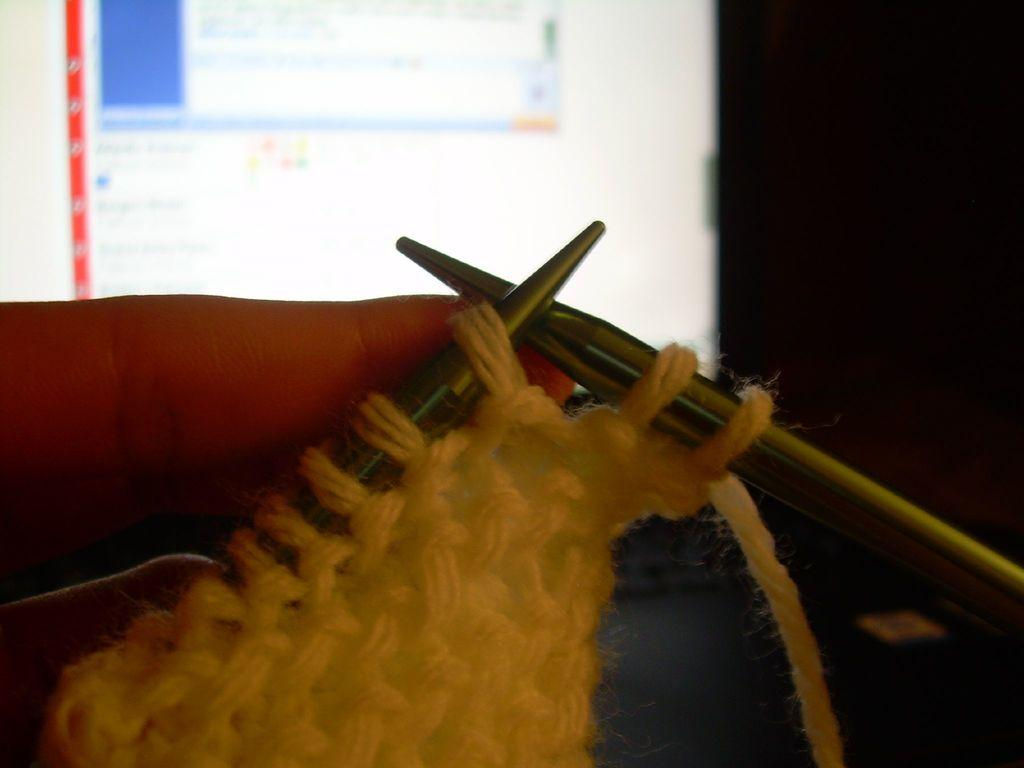What can be seen in the image related to sewing? There is a hand, two needles, and a thread in the image related to sewing. What is being sewn in the background? Something is being sewn in the background, but the specific object cannot be determined from the image. What is the color of the wall in the background? There is a white color wall in the background. What else is on the wall in the background? There are posters on the wall in the background. What type of pen is being used to draw on the texture of the wall in the image? There is no pen or texture visible in the image; it only shows a hand, needles, thread, and posters on a white wall. 